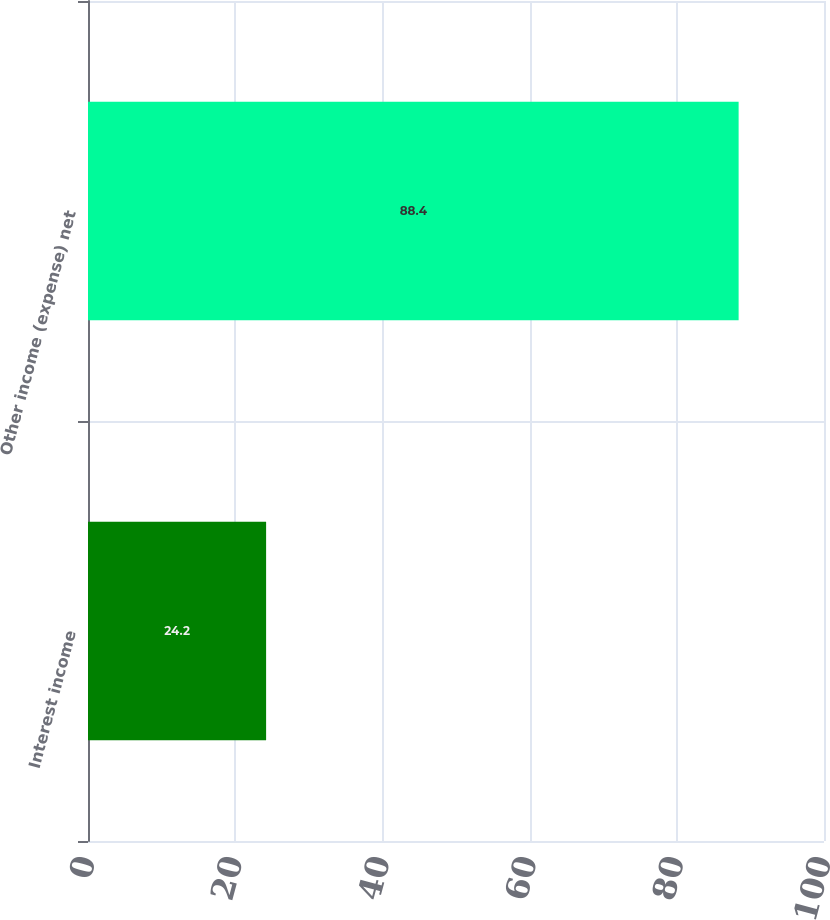Convert chart to OTSL. <chart><loc_0><loc_0><loc_500><loc_500><bar_chart><fcel>Interest income<fcel>Other income (expense) net<nl><fcel>24.2<fcel>88.4<nl></chart> 